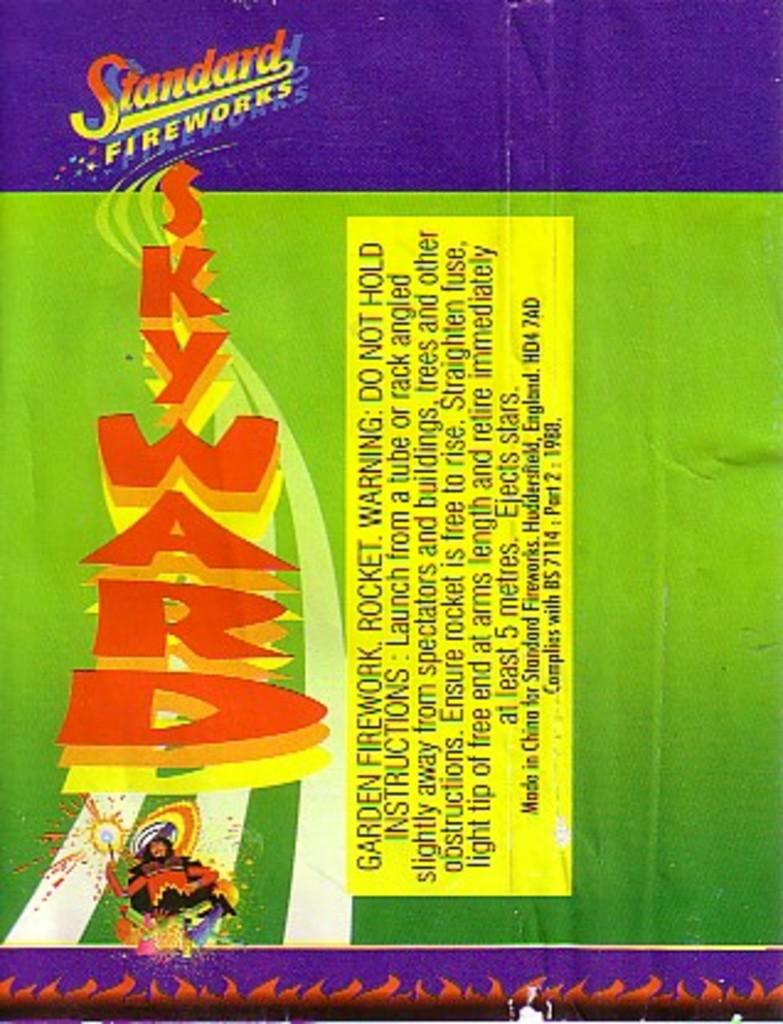What is the brand for this firework label?
Offer a very short reply. Standard fireworks. Where were these fireworks made?
Ensure brevity in your answer.  China. 